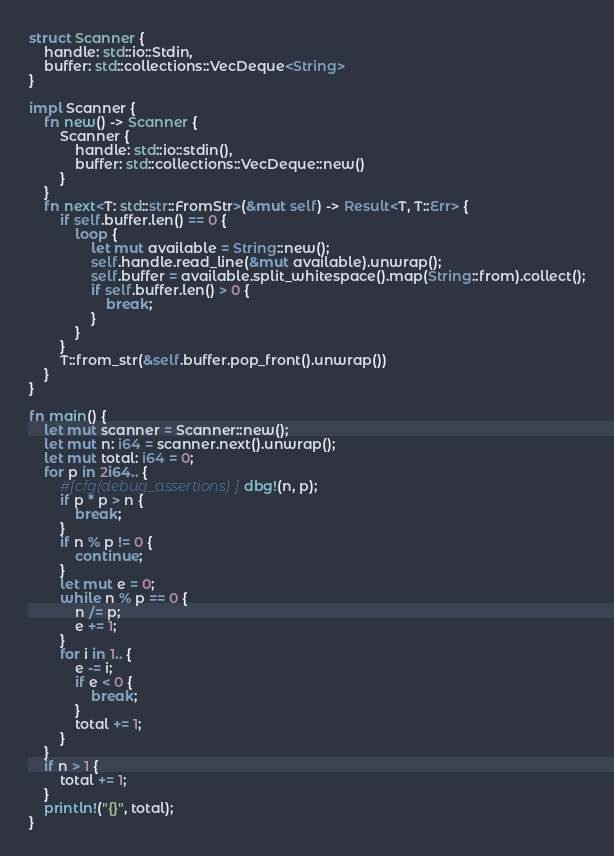Convert code to text. <code><loc_0><loc_0><loc_500><loc_500><_Rust_>struct Scanner {
	handle: std::io::Stdin,
	buffer: std::collections::VecDeque<String>
}

impl Scanner {
	fn new() -> Scanner {
		Scanner {
			handle: std::io::stdin(),
			buffer: std::collections::VecDeque::new()
		}
	}
	fn next<T: std::str::FromStr>(&mut self) -> Result<T, T::Err> {
		if self.buffer.len() == 0 {
			loop {
				let mut available = String::new();
				self.handle.read_line(&mut available).unwrap();
				self.buffer = available.split_whitespace().map(String::from).collect();
				if self.buffer.len() > 0 {
					break;
				}
			}
		}
		T::from_str(&self.buffer.pop_front().unwrap())
	}
}

fn main() {
	let mut scanner = Scanner::new();
	let mut n: i64 = scanner.next().unwrap();
	let mut total: i64 = 0;
	for p in 2i64.. {
		#[cfg(debug_assertions)] dbg!(n, p);
		if p * p > n {
			break;
		}
		if n % p != 0 {
			continue;
		}
		let mut e = 0;
		while n % p == 0 {
			n /= p;
			e += 1;
		}
		for i in 1.. {
			e -= i;
			if e < 0 {
				break;
			}
			total += 1;
		}
	}
	if n > 1 {
		total += 1;
	}
	println!("{}", total);
}
</code> 